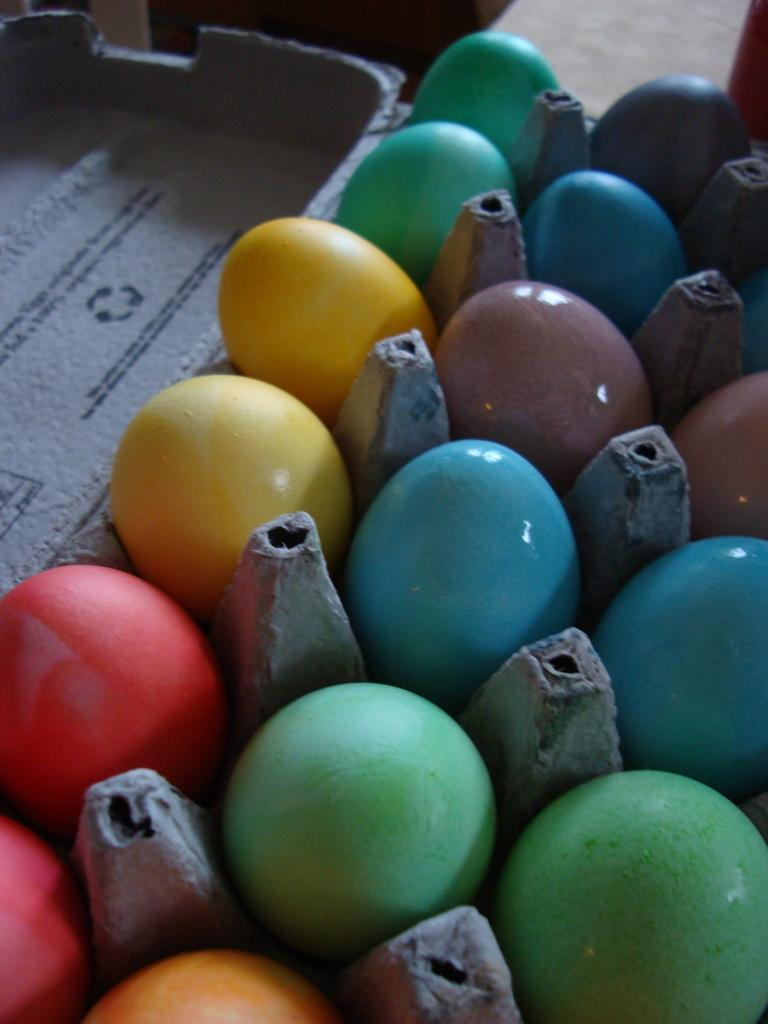What type of eggs are visible in the image? There are colored eggs in the image. How are the colored eggs arranged in the image? The colored eggs are placed on a tray. What type of sponge is used to clean the colored eggs in the image? There is no sponge present in the image, and the colored eggs are not being cleaned. 